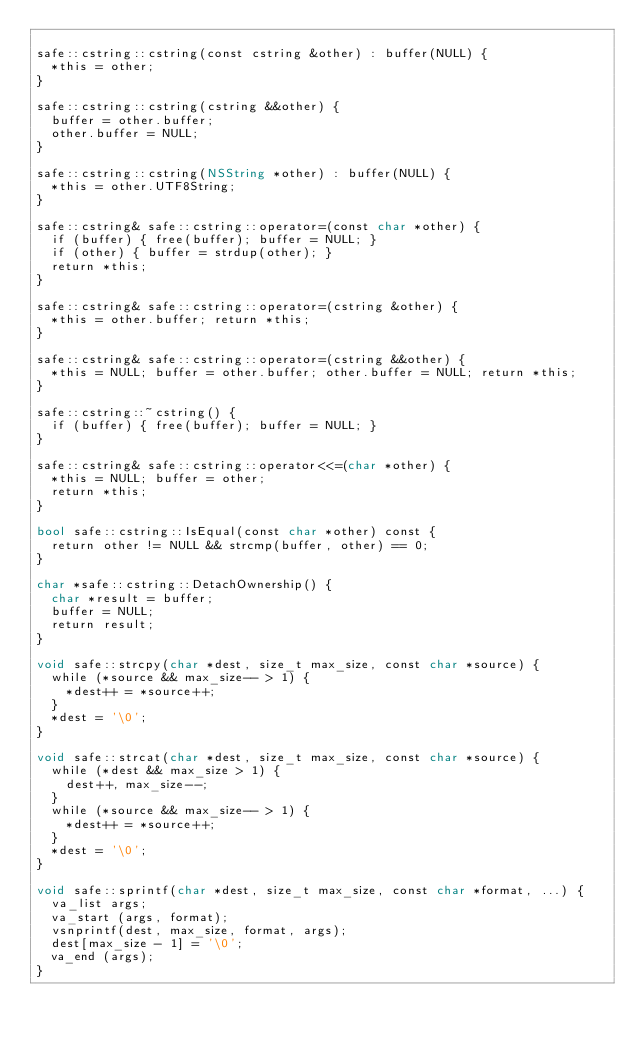Convert code to text. <code><loc_0><loc_0><loc_500><loc_500><_ObjectiveC_>
safe::cstring::cstring(const cstring &other) : buffer(NULL) {
	*this = other;
}

safe::cstring::cstring(cstring &&other) {
	buffer = other.buffer;
	other.buffer = NULL;
}

safe::cstring::cstring(NSString *other) : buffer(NULL) {
	*this = other.UTF8String;
}

safe::cstring& safe::cstring::operator=(const char *other) {
	if (buffer) { free(buffer); buffer = NULL; }
	if (other) { buffer = strdup(other); }
	return *this;
}

safe::cstring& safe::cstring::operator=(cstring &other) {
	*this = other.buffer; return *this;
}

safe::cstring& safe::cstring::operator=(cstring &&other) {
	*this = NULL; buffer = other.buffer; other.buffer = NULL; return *this;
}

safe::cstring::~cstring() {
	if (buffer) { free(buffer); buffer = NULL; }
}

safe::cstring& safe::cstring::operator<<=(char *other) {
	*this = NULL; buffer = other;
	return *this;
}

bool safe::cstring::IsEqual(const char *other) const {
	return other != NULL && strcmp(buffer, other) == 0;
}

char *safe::cstring::DetachOwnership() {
	char *result = buffer;
	buffer = NULL;
	return result;
}

void safe::strcpy(char *dest, size_t max_size, const char *source) {
	while (*source && max_size-- > 1) {
		*dest++ = *source++;
	}
	*dest = '\0';
}

void safe::strcat(char *dest, size_t max_size, const char *source) {
	while (*dest && max_size > 1) {
		dest++, max_size--;
	}
	while (*source && max_size-- > 1) {
		*dest++ = *source++;
	}
	*dest = '\0';
}

void safe::sprintf(char *dest, size_t max_size, const char *format, ...) {
	va_list args;
	va_start (args, format);
	vsnprintf(dest, max_size, format, args);
	dest[max_size - 1] = '\0';
	va_end (args);
}
</code> 